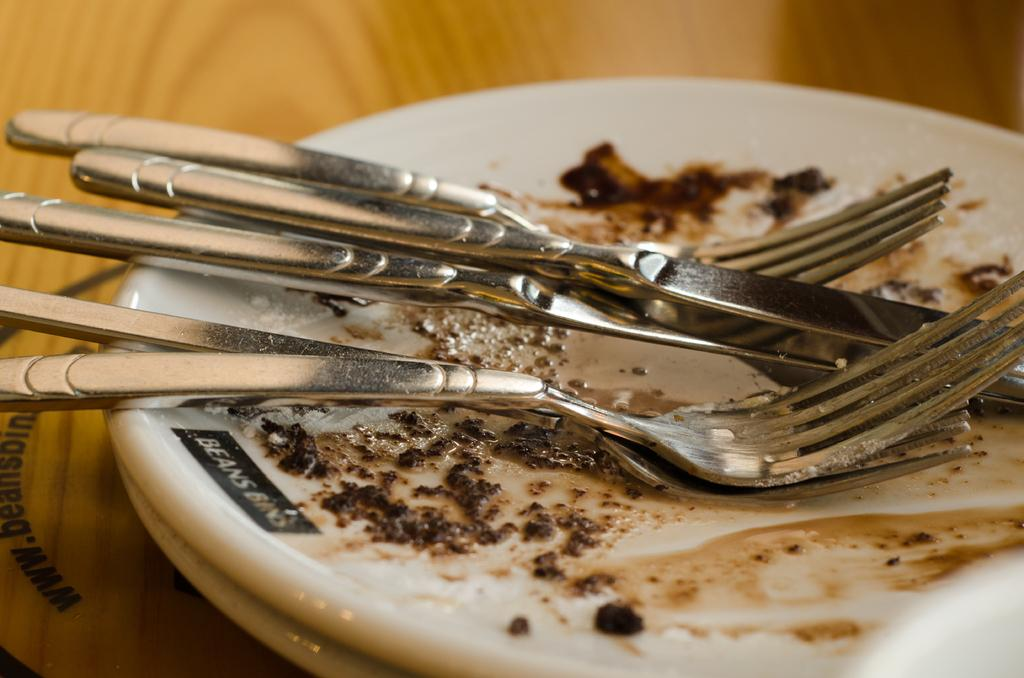What objects are present on the plates in the image? The plates have spoons on them in the image. What type of surface is visible in the image? There is a wooden surface in the image. Can you describe what is written or depicted on the left side of the image? There is some text visible on the left side of the image. What type of thunder can be heard in the image? There is no sound, including thunder, present in the image. Can you describe the zipper on the plate in the image? There is no zipper present on the plates or anywhere else in the image. 